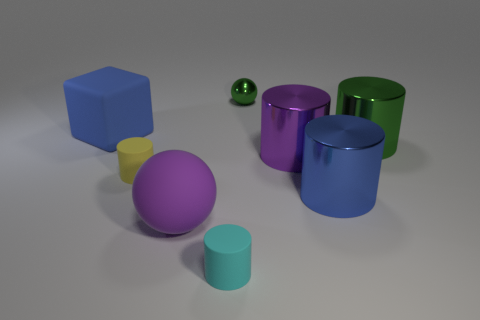Subtract all metallic cylinders. How many cylinders are left? 2 Add 1 metallic things. How many objects exist? 9 Subtract all purple cylinders. How many cylinders are left? 4 Subtract all cubes. How many objects are left? 7 Subtract 1 cylinders. How many cylinders are left? 4 Subtract all blue cylinders. Subtract all gray blocks. How many cylinders are left? 4 Subtract all large green shiny things. Subtract all small cyan matte cylinders. How many objects are left? 6 Add 8 blue shiny objects. How many blue shiny objects are left? 9 Add 3 balls. How many balls exist? 5 Subtract 0 cyan balls. How many objects are left? 8 